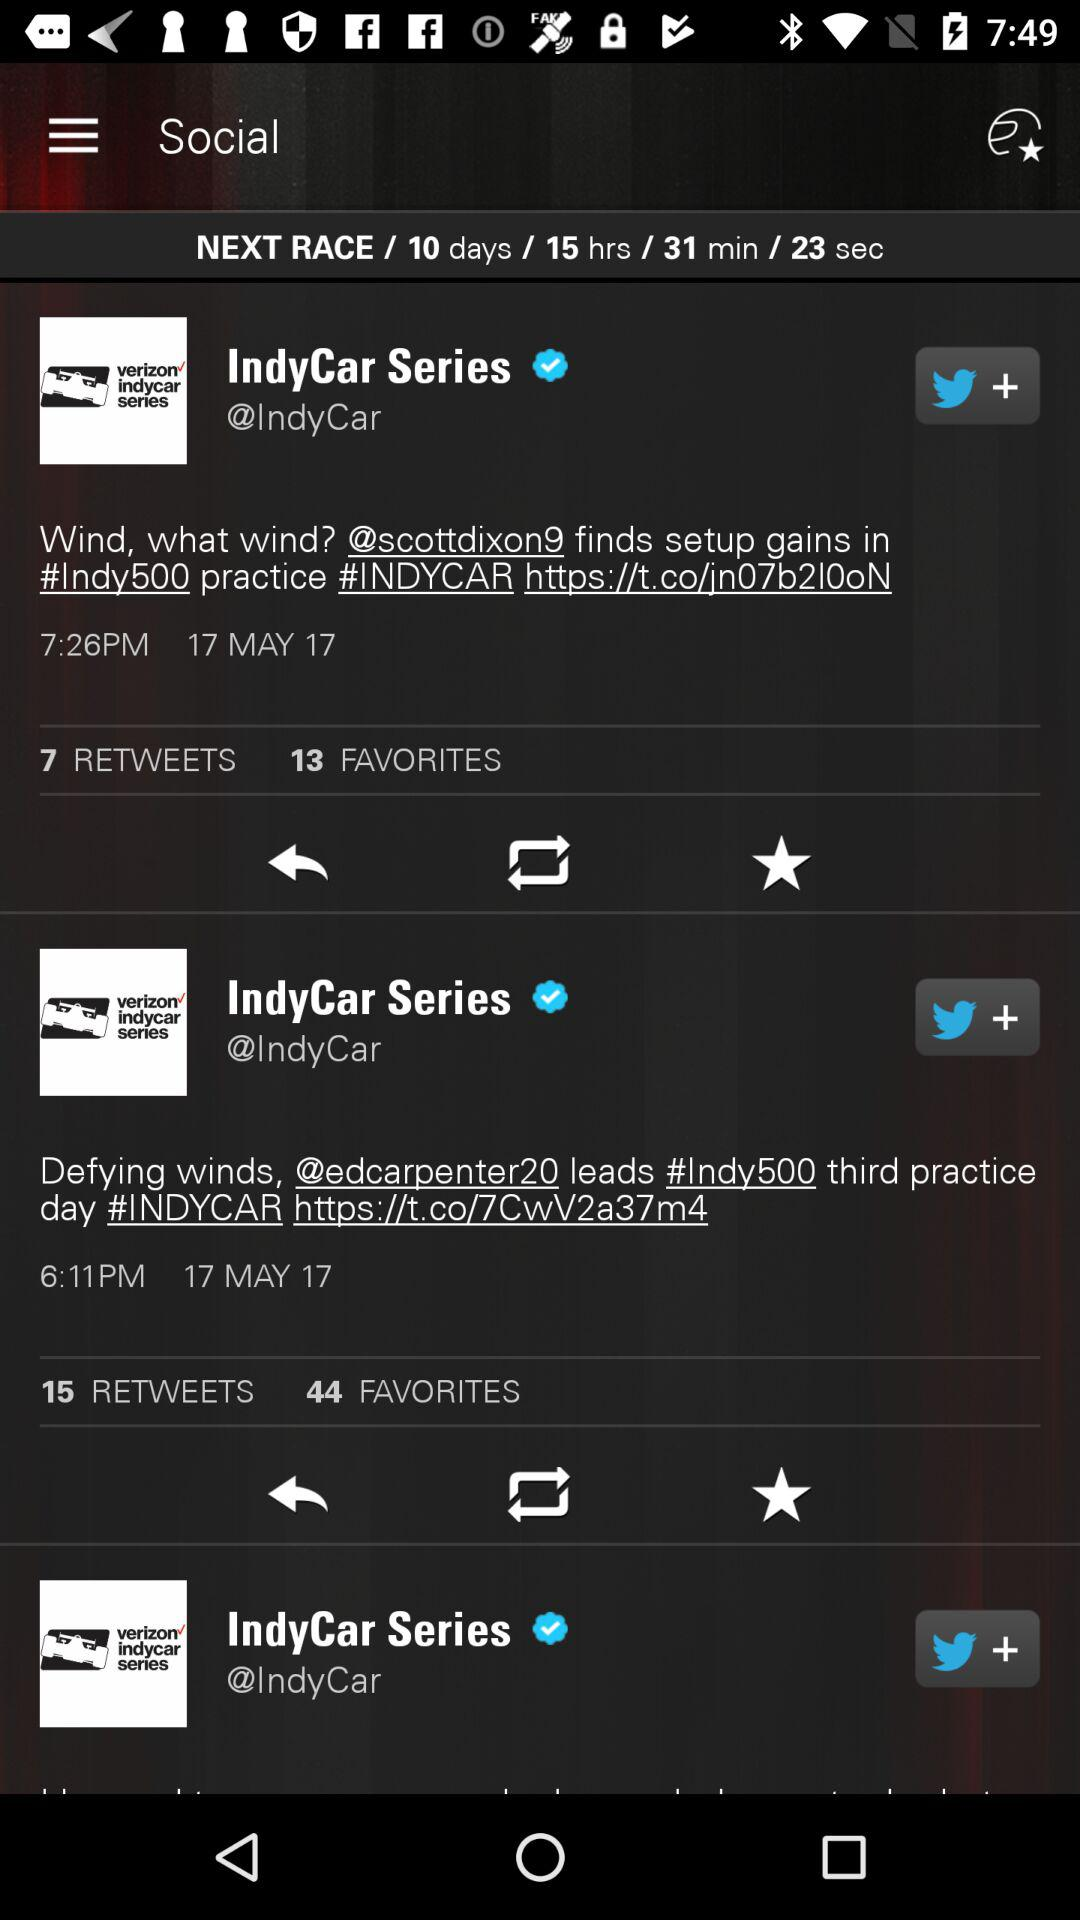What is the date of the tweet? The date is May 17, 2017. 